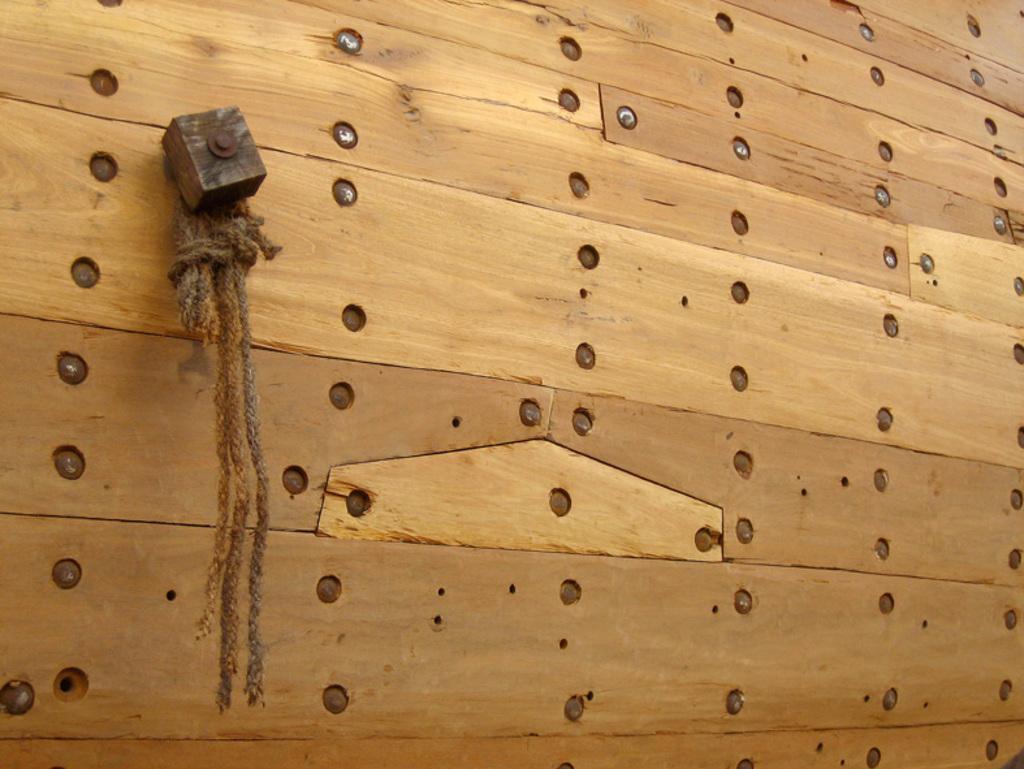How would you summarize this image in a sentence or two? In this image there is a wooden board on which there are small holes. In the holes there are screws. At the top there is a small wooden block which is attached to the board. To the block there are ropes. 